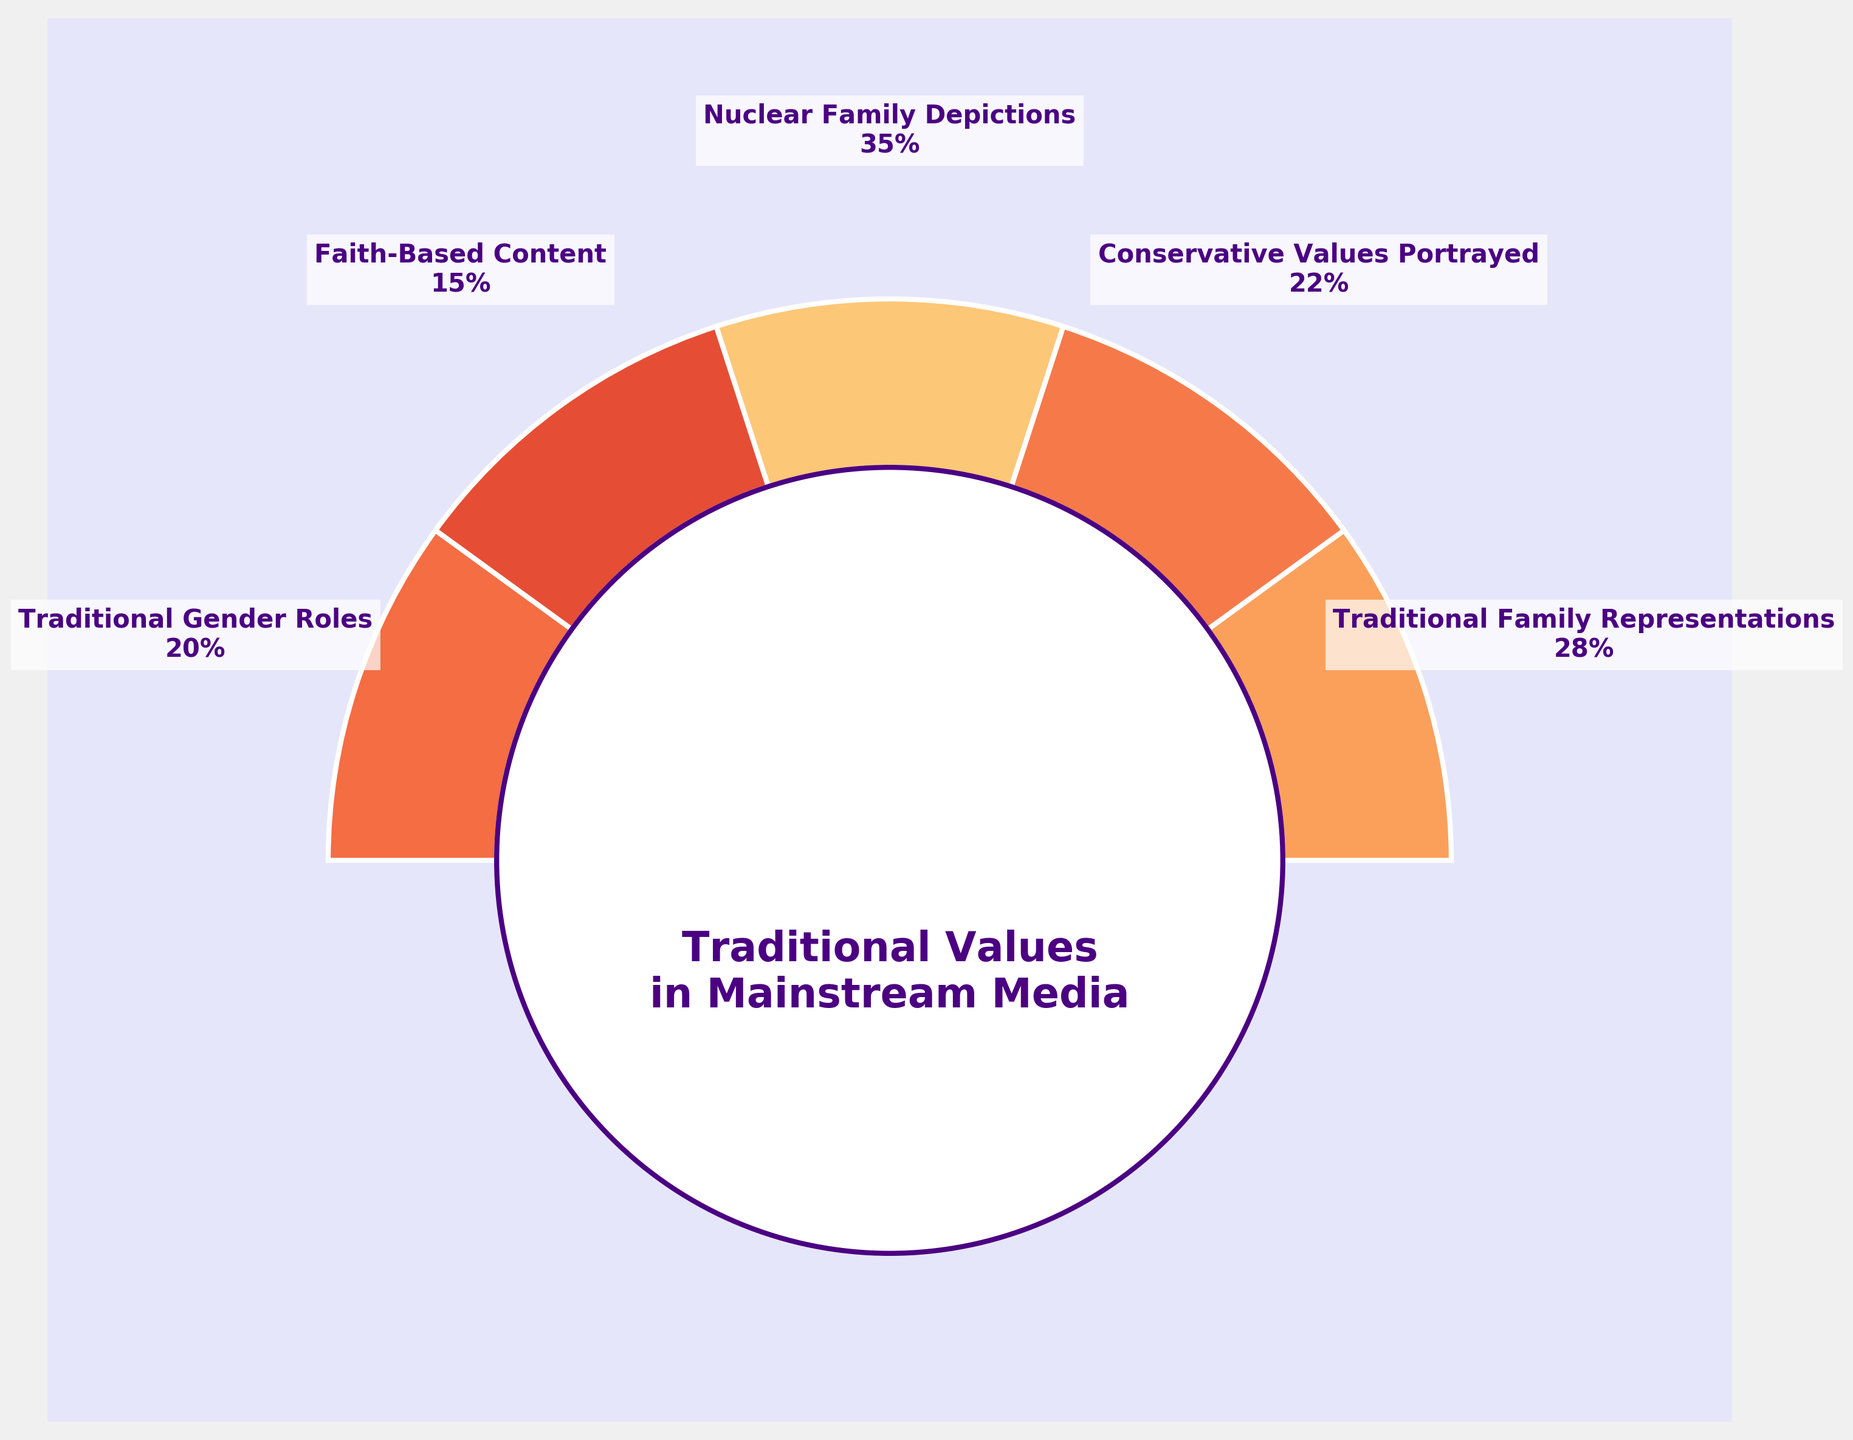What is the title of the gauge chart? The title of the chart is "Traditional Values in Mainstream Media", and it is located just below the center circle in the chart.
Answer: Traditional Values in Mainstream Media How many categories are depicted in the gauge chart? By counting the segments and their labels on the chart, we see that there are five categories depicted.
Answer: 5 Which category has the highest percentage representation? By examining the values shown in the segments of the gauge chart, "Nuclear Family Depictions" has the highest representation at 35%.
Answer: Nuclear Family Depictions What is the combined percentage for "Traditional Family Representations" and "Conservative Values Portrayed"? Adding the values for "Traditional Family Representations" (28%) and "Conservative Values Portrayed" (22%) gives 28 + 22 = 50%.
Answer: 50% Which category is represented the least in the gauge chart? Among all the categories, "Faith-Based Content" has the lowest percentage at 15%, as seen in the segment labels.
Answer: Faith-Based Content What is the difference in percentage between "Nuclear Family Depictions" and "Traditional Gender Roles"? The percentage for "Nuclear Family Depictions" is 35%, and for "Traditional Gender Roles" it is 20%. The difference is 35 - 20 = 15%.
Answer: 15% Is the sum of the percentages for "Conservative Values Portrayed" and "Faith-Based Content" greater than for "Traditional Family Representations"? "Conservative Values Portrayed" is 22% and "Faith-Based Content" is 15%. Their sum is 22 + 15 = 37%. "Traditional Family Representations" is 28%. So, 37% is greater than 28%.
Answer: Yes If you were to average the percentages of all the categories, what would it be? Adding the percentages of all the categories: 28 + 22 + 35 + 15 + 20 = 120%. Since there are five categories, the average is 120 / 5 = 24%.
Answer: 24% Comparing "Faith-Based Content" and "Traditional Gender Roles", which has a higher percentage and by how much? "Traditional Gender Roles" has 20% while "Faith-Based Content" has 15%. The difference is 20 - 15 = 5%.
Answer: Traditional Gender Roles by 5% Are there any categories that have an equal percentage representation? From the visual labels in the chart, none of the categories share the same percentage.
Answer: No 